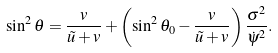<formula> <loc_0><loc_0><loc_500><loc_500>\sin ^ { 2 } \theta = \frac { v } { \tilde { u } + v } + \left ( \sin ^ { 2 } \theta _ { 0 } - \frac { v } { \tilde { u } + v } \right ) \frac { \sigma ^ { 2 } } { \dot { \psi } ^ { 2 } } .</formula> 